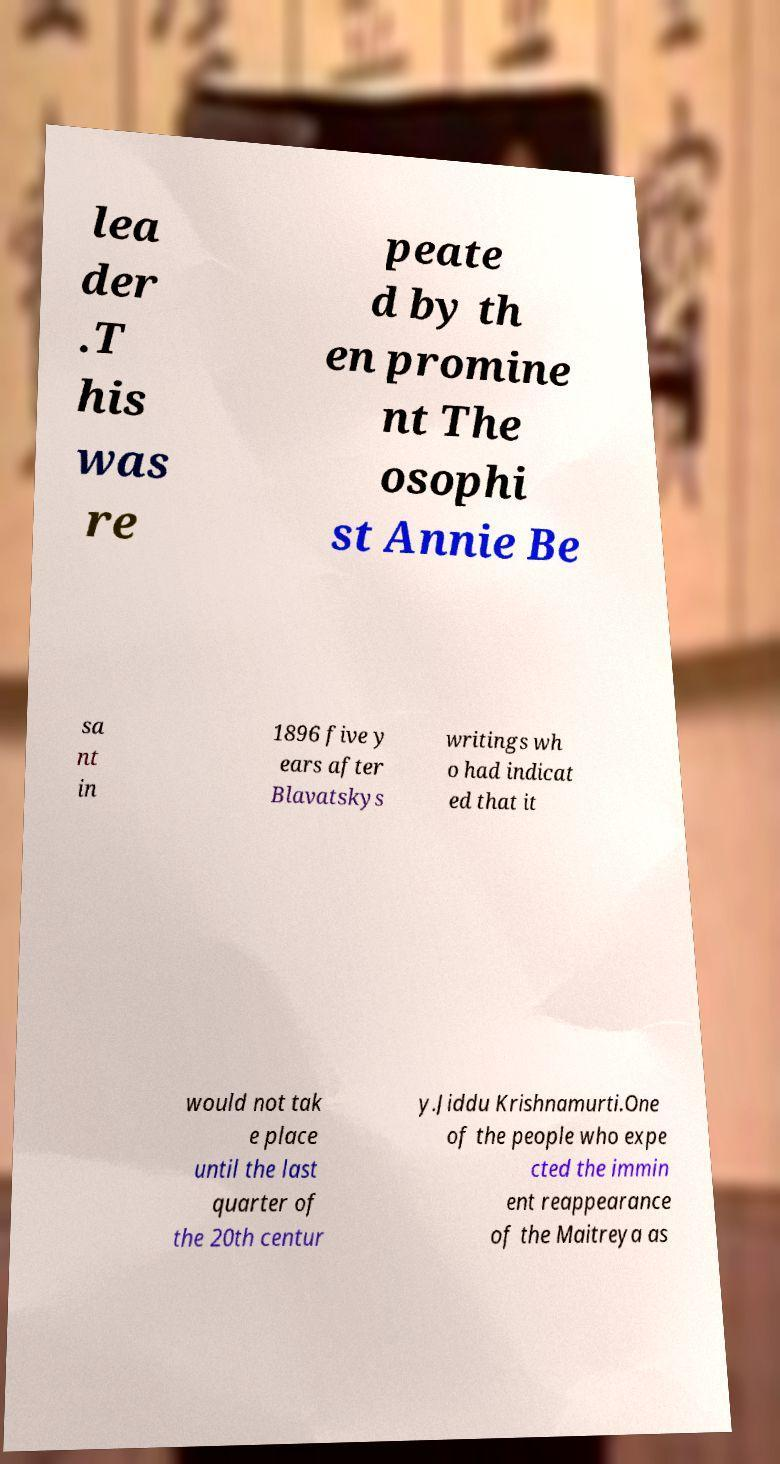Please identify and transcribe the text found in this image. lea der .T his was re peate d by th en promine nt The osophi st Annie Be sa nt in 1896 five y ears after Blavatskys writings wh o had indicat ed that it would not tak e place until the last quarter of the 20th centur y.Jiddu Krishnamurti.One of the people who expe cted the immin ent reappearance of the Maitreya as 